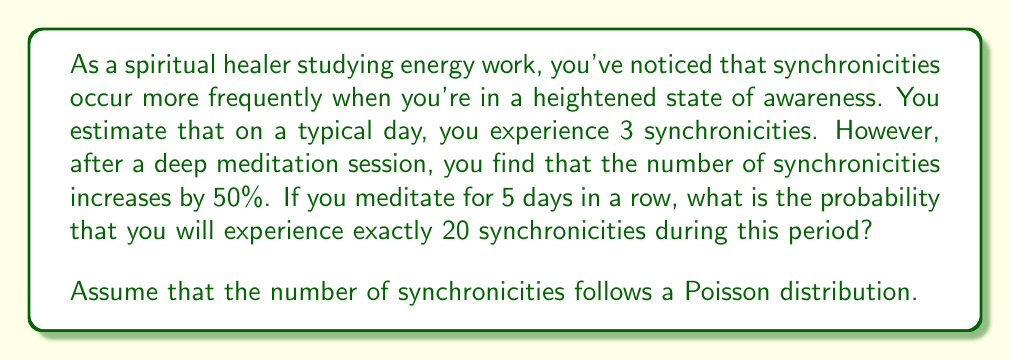Can you solve this math problem? To solve this problem, we'll use the Poisson distribution, which is suitable for modeling the number of events occurring in a fixed interval of time or space.

1. Calculate the average number of synchronicities per day after meditation:
   $\lambda_{meditation} = 3 \times 1.5 = 4.5$ synchronicities per day

2. Calculate the total average number of synchronicities for 5 days:
   $\lambda_{total} = 4.5 \times 5 = 22.5$ synchronicities

3. Use the Poisson probability mass function:
   $$P(X = k) = \frac{e^{-\lambda} \lambda^k}{k!}$$
   where $\lambda$ is the average number of events and $k$ is the number of events we're interested in.

4. Plug in the values:
   $$P(X = 20) = \frac{e^{-22.5} 22.5^{20}}{20!}$$

5. Calculate the result:
   $$P(X = 20) \approx 0.0739$$

This can be computed using a calculator or programming language with support for large numbers and exponentials.
Answer: The probability of experiencing exactly 20 synchronicities during the 5-day meditation period is approximately 0.0739 or 7.39%. 